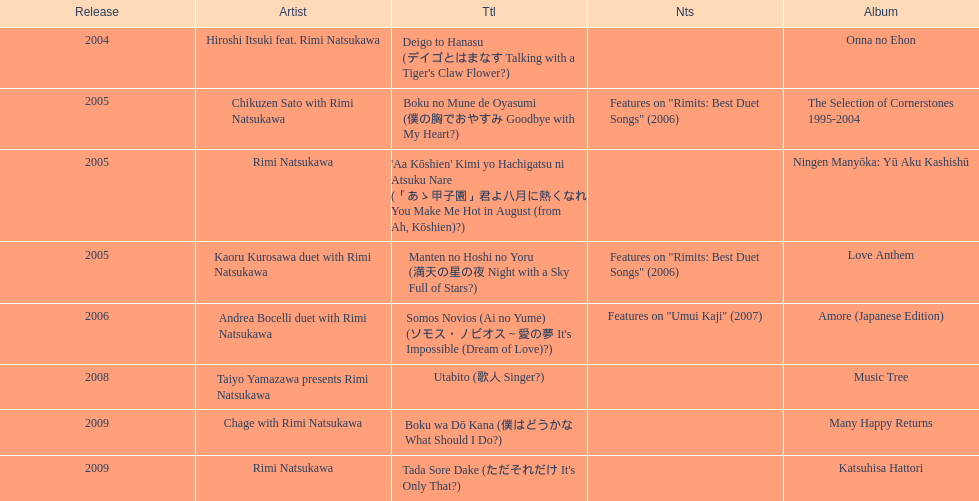Which was released earlier, deigo to hanasu or utabito? Deigo to Hanasu. Can you give me this table as a dict? {'header': ['Release', 'Artist', 'Ttl', 'Nts', 'Album'], 'rows': [['2004', 'Hiroshi Itsuki feat. Rimi Natsukawa', "Deigo to Hanasu (デイゴとはまなす Talking with a Tiger's Claw Flower?)", '', 'Onna no Ehon'], ['2005', 'Chikuzen Sato with Rimi Natsukawa', 'Boku no Mune de Oyasumi (僕の胸でおやすみ Goodbye with My Heart?)', 'Features on "Rimits: Best Duet Songs" (2006)', 'The Selection of Cornerstones 1995-2004'], ['2005', 'Rimi Natsukawa', "'Aa Kōshien' Kimi yo Hachigatsu ni Atsuku Nare (「あゝ甲子園」君よ八月に熱くなれ You Make Me Hot in August (from Ah, Kōshien)?)", '', 'Ningen Manyōka: Yū Aku Kashishū'], ['2005', 'Kaoru Kurosawa duet with Rimi Natsukawa', 'Manten no Hoshi no Yoru (満天の星の夜 Night with a Sky Full of Stars?)', 'Features on "Rimits: Best Duet Songs" (2006)', 'Love Anthem'], ['2006', 'Andrea Bocelli duet with Rimi Natsukawa', "Somos Novios (Ai no Yume) (ソモス・ノビオス～愛の夢 It's Impossible (Dream of Love)?)", 'Features on "Umui Kaji" (2007)', 'Amore (Japanese Edition)'], ['2008', 'Taiyo Yamazawa presents Rimi Natsukawa', 'Utabito (歌人 Singer?)', '', 'Music Tree'], ['2009', 'Chage with Rimi Natsukawa', 'Boku wa Dō Kana (僕はどうかな What Should I Do?)', '', 'Many Happy Returns'], ['2009', 'Rimi Natsukawa', "Tada Sore Dake (ただそれだけ It's Only That?)", '', 'Katsuhisa Hattori']]} 